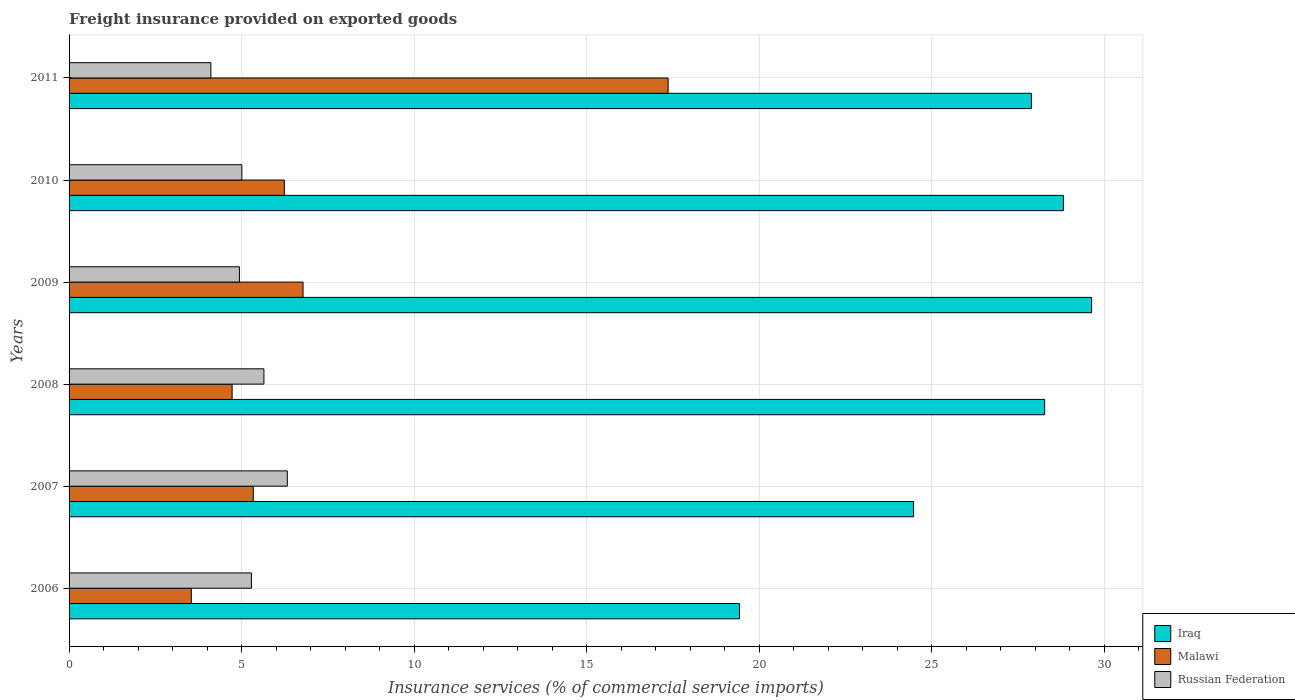How many different coloured bars are there?
Provide a succinct answer. 3. What is the freight insurance provided on exported goods in Malawi in 2010?
Provide a succinct answer. 6.24. Across all years, what is the maximum freight insurance provided on exported goods in Russian Federation?
Provide a succinct answer. 6.33. Across all years, what is the minimum freight insurance provided on exported goods in Russian Federation?
Your answer should be very brief. 4.11. In which year was the freight insurance provided on exported goods in Malawi minimum?
Your response must be concise. 2006. What is the total freight insurance provided on exported goods in Iraq in the graph?
Offer a very short reply. 158.54. What is the difference between the freight insurance provided on exported goods in Iraq in 2009 and that in 2010?
Your answer should be compact. 0.82. What is the difference between the freight insurance provided on exported goods in Russian Federation in 2009 and the freight insurance provided on exported goods in Iraq in 2007?
Keep it short and to the point. -19.54. What is the average freight insurance provided on exported goods in Malawi per year?
Offer a very short reply. 7.33. In the year 2007, what is the difference between the freight insurance provided on exported goods in Malawi and freight insurance provided on exported goods in Russian Federation?
Provide a succinct answer. -0.99. What is the ratio of the freight insurance provided on exported goods in Iraq in 2006 to that in 2011?
Ensure brevity in your answer.  0.7. Is the difference between the freight insurance provided on exported goods in Malawi in 2007 and 2010 greater than the difference between the freight insurance provided on exported goods in Russian Federation in 2007 and 2010?
Give a very brief answer. No. What is the difference between the highest and the second highest freight insurance provided on exported goods in Russian Federation?
Ensure brevity in your answer.  0.68. What is the difference between the highest and the lowest freight insurance provided on exported goods in Malawi?
Offer a very short reply. 13.82. In how many years, is the freight insurance provided on exported goods in Iraq greater than the average freight insurance provided on exported goods in Iraq taken over all years?
Provide a succinct answer. 4. Is the sum of the freight insurance provided on exported goods in Russian Federation in 2006 and 2007 greater than the maximum freight insurance provided on exported goods in Malawi across all years?
Offer a terse response. No. What does the 2nd bar from the top in 2010 represents?
Keep it short and to the point. Malawi. What does the 2nd bar from the bottom in 2010 represents?
Your answer should be compact. Malawi. Is it the case that in every year, the sum of the freight insurance provided on exported goods in Russian Federation and freight insurance provided on exported goods in Malawi is greater than the freight insurance provided on exported goods in Iraq?
Offer a terse response. No. How many bars are there?
Your response must be concise. 18. How many years are there in the graph?
Your answer should be very brief. 6. Are the values on the major ticks of X-axis written in scientific E-notation?
Your response must be concise. No. How are the legend labels stacked?
Your answer should be very brief. Vertical. What is the title of the graph?
Offer a terse response. Freight insurance provided on exported goods. What is the label or title of the X-axis?
Provide a succinct answer. Insurance services (% of commercial service imports). What is the Insurance services (% of commercial service imports) of Iraq in 2006?
Provide a short and direct response. 19.43. What is the Insurance services (% of commercial service imports) in Malawi in 2006?
Provide a short and direct response. 3.54. What is the Insurance services (% of commercial service imports) in Russian Federation in 2006?
Provide a short and direct response. 5.29. What is the Insurance services (% of commercial service imports) in Iraq in 2007?
Make the answer very short. 24.48. What is the Insurance services (% of commercial service imports) of Malawi in 2007?
Make the answer very short. 5.34. What is the Insurance services (% of commercial service imports) of Russian Federation in 2007?
Make the answer very short. 6.33. What is the Insurance services (% of commercial service imports) of Iraq in 2008?
Offer a terse response. 28.28. What is the Insurance services (% of commercial service imports) in Malawi in 2008?
Ensure brevity in your answer.  4.73. What is the Insurance services (% of commercial service imports) in Russian Federation in 2008?
Keep it short and to the point. 5.65. What is the Insurance services (% of commercial service imports) in Iraq in 2009?
Give a very brief answer. 29.64. What is the Insurance services (% of commercial service imports) of Malawi in 2009?
Your answer should be compact. 6.78. What is the Insurance services (% of commercial service imports) of Russian Federation in 2009?
Keep it short and to the point. 4.94. What is the Insurance services (% of commercial service imports) in Iraq in 2010?
Offer a terse response. 28.82. What is the Insurance services (% of commercial service imports) of Malawi in 2010?
Make the answer very short. 6.24. What is the Insurance services (% of commercial service imports) of Russian Federation in 2010?
Your answer should be very brief. 5.01. What is the Insurance services (% of commercial service imports) of Iraq in 2011?
Your answer should be very brief. 27.89. What is the Insurance services (% of commercial service imports) of Malawi in 2011?
Offer a terse response. 17.36. What is the Insurance services (% of commercial service imports) in Russian Federation in 2011?
Ensure brevity in your answer.  4.11. Across all years, what is the maximum Insurance services (% of commercial service imports) in Iraq?
Your response must be concise. 29.64. Across all years, what is the maximum Insurance services (% of commercial service imports) in Malawi?
Give a very brief answer. 17.36. Across all years, what is the maximum Insurance services (% of commercial service imports) in Russian Federation?
Provide a succinct answer. 6.33. Across all years, what is the minimum Insurance services (% of commercial service imports) in Iraq?
Provide a short and direct response. 19.43. Across all years, what is the minimum Insurance services (% of commercial service imports) in Malawi?
Your answer should be compact. 3.54. Across all years, what is the minimum Insurance services (% of commercial service imports) of Russian Federation?
Make the answer very short. 4.11. What is the total Insurance services (% of commercial service imports) in Iraq in the graph?
Keep it short and to the point. 158.54. What is the total Insurance services (% of commercial service imports) of Malawi in the graph?
Give a very brief answer. 43.99. What is the total Insurance services (% of commercial service imports) in Russian Federation in the graph?
Give a very brief answer. 31.32. What is the difference between the Insurance services (% of commercial service imports) of Iraq in 2006 and that in 2007?
Your answer should be very brief. -5.05. What is the difference between the Insurance services (% of commercial service imports) of Malawi in 2006 and that in 2007?
Give a very brief answer. -1.79. What is the difference between the Insurance services (% of commercial service imports) in Russian Federation in 2006 and that in 2007?
Keep it short and to the point. -1.04. What is the difference between the Insurance services (% of commercial service imports) in Iraq in 2006 and that in 2008?
Give a very brief answer. -8.85. What is the difference between the Insurance services (% of commercial service imports) of Malawi in 2006 and that in 2008?
Provide a succinct answer. -1.18. What is the difference between the Insurance services (% of commercial service imports) in Russian Federation in 2006 and that in 2008?
Your answer should be very brief. -0.36. What is the difference between the Insurance services (% of commercial service imports) of Iraq in 2006 and that in 2009?
Offer a very short reply. -10.21. What is the difference between the Insurance services (% of commercial service imports) in Malawi in 2006 and that in 2009?
Make the answer very short. -3.24. What is the difference between the Insurance services (% of commercial service imports) of Russian Federation in 2006 and that in 2009?
Make the answer very short. 0.35. What is the difference between the Insurance services (% of commercial service imports) in Iraq in 2006 and that in 2010?
Offer a terse response. -9.39. What is the difference between the Insurance services (% of commercial service imports) in Malawi in 2006 and that in 2010?
Ensure brevity in your answer.  -2.7. What is the difference between the Insurance services (% of commercial service imports) in Russian Federation in 2006 and that in 2010?
Provide a short and direct response. 0.28. What is the difference between the Insurance services (% of commercial service imports) in Iraq in 2006 and that in 2011?
Give a very brief answer. -8.46. What is the difference between the Insurance services (% of commercial service imports) of Malawi in 2006 and that in 2011?
Provide a short and direct response. -13.82. What is the difference between the Insurance services (% of commercial service imports) of Russian Federation in 2006 and that in 2011?
Offer a terse response. 1.18. What is the difference between the Insurance services (% of commercial service imports) in Iraq in 2007 and that in 2008?
Your answer should be very brief. -3.8. What is the difference between the Insurance services (% of commercial service imports) of Malawi in 2007 and that in 2008?
Offer a very short reply. 0.61. What is the difference between the Insurance services (% of commercial service imports) in Russian Federation in 2007 and that in 2008?
Offer a very short reply. 0.68. What is the difference between the Insurance services (% of commercial service imports) in Iraq in 2007 and that in 2009?
Provide a short and direct response. -5.16. What is the difference between the Insurance services (% of commercial service imports) of Malawi in 2007 and that in 2009?
Keep it short and to the point. -1.44. What is the difference between the Insurance services (% of commercial service imports) of Russian Federation in 2007 and that in 2009?
Keep it short and to the point. 1.39. What is the difference between the Insurance services (% of commercial service imports) of Iraq in 2007 and that in 2010?
Make the answer very short. -4.34. What is the difference between the Insurance services (% of commercial service imports) in Malawi in 2007 and that in 2010?
Offer a very short reply. -0.9. What is the difference between the Insurance services (% of commercial service imports) in Russian Federation in 2007 and that in 2010?
Keep it short and to the point. 1.32. What is the difference between the Insurance services (% of commercial service imports) of Iraq in 2007 and that in 2011?
Give a very brief answer. -3.42. What is the difference between the Insurance services (% of commercial service imports) in Malawi in 2007 and that in 2011?
Provide a short and direct response. -12.02. What is the difference between the Insurance services (% of commercial service imports) in Russian Federation in 2007 and that in 2011?
Your response must be concise. 2.22. What is the difference between the Insurance services (% of commercial service imports) in Iraq in 2008 and that in 2009?
Ensure brevity in your answer.  -1.36. What is the difference between the Insurance services (% of commercial service imports) of Malawi in 2008 and that in 2009?
Offer a terse response. -2.06. What is the difference between the Insurance services (% of commercial service imports) in Russian Federation in 2008 and that in 2009?
Offer a terse response. 0.71. What is the difference between the Insurance services (% of commercial service imports) in Iraq in 2008 and that in 2010?
Ensure brevity in your answer.  -0.54. What is the difference between the Insurance services (% of commercial service imports) of Malawi in 2008 and that in 2010?
Ensure brevity in your answer.  -1.51. What is the difference between the Insurance services (% of commercial service imports) of Russian Federation in 2008 and that in 2010?
Offer a terse response. 0.64. What is the difference between the Insurance services (% of commercial service imports) in Iraq in 2008 and that in 2011?
Your answer should be very brief. 0.38. What is the difference between the Insurance services (% of commercial service imports) of Malawi in 2008 and that in 2011?
Keep it short and to the point. -12.64. What is the difference between the Insurance services (% of commercial service imports) of Russian Federation in 2008 and that in 2011?
Provide a short and direct response. 1.54. What is the difference between the Insurance services (% of commercial service imports) of Iraq in 2009 and that in 2010?
Offer a terse response. 0.82. What is the difference between the Insurance services (% of commercial service imports) of Malawi in 2009 and that in 2010?
Offer a terse response. 0.54. What is the difference between the Insurance services (% of commercial service imports) of Russian Federation in 2009 and that in 2010?
Offer a terse response. -0.07. What is the difference between the Insurance services (% of commercial service imports) of Iraq in 2009 and that in 2011?
Your answer should be compact. 1.75. What is the difference between the Insurance services (% of commercial service imports) in Malawi in 2009 and that in 2011?
Make the answer very short. -10.58. What is the difference between the Insurance services (% of commercial service imports) of Russian Federation in 2009 and that in 2011?
Your response must be concise. 0.83. What is the difference between the Insurance services (% of commercial service imports) of Iraq in 2010 and that in 2011?
Make the answer very short. 0.93. What is the difference between the Insurance services (% of commercial service imports) of Malawi in 2010 and that in 2011?
Give a very brief answer. -11.12. What is the difference between the Insurance services (% of commercial service imports) of Russian Federation in 2010 and that in 2011?
Your response must be concise. 0.9. What is the difference between the Insurance services (% of commercial service imports) in Iraq in 2006 and the Insurance services (% of commercial service imports) in Malawi in 2007?
Provide a short and direct response. 14.09. What is the difference between the Insurance services (% of commercial service imports) of Iraq in 2006 and the Insurance services (% of commercial service imports) of Russian Federation in 2007?
Ensure brevity in your answer.  13.11. What is the difference between the Insurance services (% of commercial service imports) of Malawi in 2006 and the Insurance services (% of commercial service imports) of Russian Federation in 2007?
Provide a succinct answer. -2.78. What is the difference between the Insurance services (% of commercial service imports) of Iraq in 2006 and the Insurance services (% of commercial service imports) of Malawi in 2008?
Provide a succinct answer. 14.71. What is the difference between the Insurance services (% of commercial service imports) of Iraq in 2006 and the Insurance services (% of commercial service imports) of Russian Federation in 2008?
Your answer should be compact. 13.78. What is the difference between the Insurance services (% of commercial service imports) in Malawi in 2006 and the Insurance services (% of commercial service imports) in Russian Federation in 2008?
Your answer should be very brief. -2.1. What is the difference between the Insurance services (% of commercial service imports) of Iraq in 2006 and the Insurance services (% of commercial service imports) of Malawi in 2009?
Offer a terse response. 12.65. What is the difference between the Insurance services (% of commercial service imports) of Iraq in 2006 and the Insurance services (% of commercial service imports) of Russian Federation in 2009?
Keep it short and to the point. 14.49. What is the difference between the Insurance services (% of commercial service imports) of Malawi in 2006 and the Insurance services (% of commercial service imports) of Russian Federation in 2009?
Provide a short and direct response. -1.39. What is the difference between the Insurance services (% of commercial service imports) of Iraq in 2006 and the Insurance services (% of commercial service imports) of Malawi in 2010?
Offer a terse response. 13.19. What is the difference between the Insurance services (% of commercial service imports) of Iraq in 2006 and the Insurance services (% of commercial service imports) of Russian Federation in 2010?
Give a very brief answer. 14.42. What is the difference between the Insurance services (% of commercial service imports) of Malawi in 2006 and the Insurance services (% of commercial service imports) of Russian Federation in 2010?
Keep it short and to the point. -1.46. What is the difference between the Insurance services (% of commercial service imports) of Iraq in 2006 and the Insurance services (% of commercial service imports) of Malawi in 2011?
Give a very brief answer. 2.07. What is the difference between the Insurance services (% of commercial service imports) of Iraq in 2006 and the Insurance services (% of commercial service imports) of Russian Federation in 2011?
Provide a succinct answer. 15.32. What is the difference between the Insurance services (% of commercial service imports) of Malawi in 2006 and the Insurance services (% of commercial service imports) of Russian Federation in 2011?
Offer a very short reply. -0.57. What is the difference between the Insurance services (% of commercial service imports) of Iraq in 2007 and the Insurance services (% of commercial service imports) of Malawi in 2008?
Give a very brief answer. 19.75. What is the difference between the Insurance services (% of commercial service imports) in Iraq in 2007 and the Insurance services (% of commercial service imports) in Russian Federation in 2008?
Provide a short and direct response. 18.83. What is the difference between the Insurance services (% of commercial service imports) of Malawi in 2007 and the Insurance services (% of commercial service imports) of Russian Federation in 2008?
Your answer should be compact. -0.31. What is the difference between the Insurance services (% of commercial service imports) in Iraq in 2007 and the Insurance services (% of commercial service imports) in Malawi in 2009?
Make the answer very short. 17.7. What is the difference between the Insurance services (% of commercial service imports) of Iraq in 2007 and the Insurance services (% of commercial service imports) of Russian Federation in 2009?
Your answer should be compact. 19.54. What is the difference between the Insurance services (% of commercial service imports) of Malawi in 2007 and the Insurance services (% of commercial service imports) of Russian Federation in 2009?
Your response must be concise. 0.4. What is the difference between the Insurance services (% of commercial service imports) of Iraq in 2007 and the Insurance services (% of commercial service imports) of Malawi in 2010?
Offer a terse response. 18.24. What is the difference between the Insurance services (% of commercial service imports) in Iraq in 2007 and the Insurance services (% of commercial service imports) in Russian Federation in 2010?
Provide a short and direct response. 19.47. What is the difference between the Insurance services (% of commercial service imports) of Malawi in 2007 and the Insurance services (% of commercial service imports) of Russian Federation in 2010?
Keep it short and to the point. 0.33. What is the difference between the Insurance services (% of commercial service imports) of Iraq in 2007 and the Insurance services (% of commercial service imports) of Malawi in 2011?
Give a very brief answer. 7.11. What is the difference between the Insurance services (% of commercial service imports) of Iraq in 2007 and the Insurance services (% of commercial service imports) of Russian Federation in 2011?
Provide a short and direct response. 20.37. What is the difference between the Insurance services (% of commercial service imports) in Malawi in 2007 and the Insurance services (% of commercial service imports) in Russian Federation in 2011?
Provide a succinct answer. 1.23. What is the difference between the Insurance services (% of commercial service imports) in Iraq in 2008 and the Insurance services (% of commercial service imports) in Malawi in 2009?
Keep it short and to the point. 21.5. What is the difference between the Insurance services (% of commercial service imports) in Iraq in 2008 and the Insurance services (% of commercial service imports) in Russian Federation in 2009?
Provide a short and direct response. 23.34. What is the difference between the Insurance services (% of commercial service imports) in Malawi in 2008 and the Insurance services (% of commercial service imports) in Russian Federation in 2009?
Offer a terse response. -0.21. What is the difference between the Insurance services (% of commercial service imports) in Iraq in 2008 and the Insurance services (% of commercial service imports) in Malawi in 2010?
Give a very brief answer. 22.04. What is the difference between the Insurance services (% of commercial service imports) of Iraq in 2008 and the Insurance services (% of commercial service imports) of Russian Federation in 2010?
Keep it short and to the point. 23.27. What is the difference between the Insurance services (% of commercial service imports) of Malawi in 2008 and the Insurance services (% of commercial service imports) of Russian Federation in 2010?
Your answer should be compact. -0.28. What is the difference between the Insurance services (% of commercial service imports) in Iraq in 2008 and the Insurance services (% of commercial service imports) in Malawi in 2011?
Provide a short and direct response. 10.91. What is the difference between the Insurance services (% of commercial service imports) of Iraq in 2008 and the Insurance services (% of commercial service imports) of Russian Federation in 2011?
Your answer should be very brief. 24.17. What is the difference between the Insurance services (% of commercial service imports) in Malawi in 2008 and the Insurance services (% of commercial service imports) in Russian Federation in 2011?
Make the answer very short. 0.62. What is the difference between the Insurance services (% of commercial service imports) in Iraq in 2009 and the Insurance services (% of commercial service imports) in Malawi in 2010?
Your answer should be very brief. 23.4. What is the difference between the Insurance services (% of commercial service imports) in Iraq in 2009 and the Insurance services (% of commercial service imports) in Russian Federation in 2010?
Keep it short and to the point. 24.63. What is the difference between the Insurance services (% of commercial service imports) of Malawi in 2009 and the Insurance services (% of commercial service imports) of Russian Federation in 2010?
Provide a short and direct response. 1.77. What is the difference between the Insurance services (% of commercial service imports) of Iraq in 2009 and the Insurance services (% of commercial service imports) of Malawi in 2011?
Provide a succinct answer. 12.28. What is the difference between the Insurance services (% of commercial service imports) of Iraq in 2009 and the Insurance services (% of commercial service imports) of Russian Federation in 2011?
Your answer should be compact. 25.53. What is the difference between the Insurance services (% of commercial service imports) in Malawi in 2009 and the Insurance services (% of commercial service imports) in Russian Federation in 2011?
Your answer should be very brief. 2.67. What is the difference between the Insurance services (% of commercial service imports) in Iraq in 2010 and the Insurance services (% of commercial service imports) in Malawi in 2011?
Ensure brevity in your answer.  11.46. What is the difference between the Insurance services (% of commercial service imports) of Iraq in 2010 and the Insurance services (% of commercial service imports) of Russian Federation in 2011?
Give a very brief answer. 24.71. What is the difference between the Insurance services (% of commercial service imports) of Malawi in 2010 and the Insurance services (% of commercial service imports) of Russian Federation in 2011?
Provide a short and direct response. 2.13. What is the average Insurance services (% of commercial service imports) in Iraq per year?
Your response must be concise. 26.42. What is the average Insurance services (% of commercial service imports) in Malawi per year?
Your answer should be compact. 7.33. What is the average Insurance services (% of commercial service imports) of Russian Federation per year?
Offer a terse response. 5.22. In the year 2006, what is the difference between the Insurance services (% of commercial service imports) of Iraq and Insurance services (% of commercial service imports) of Malawi?
Offer a terse response. 15.89. In the year 2006, what is the difference between the Insurance services (% of commercial service imports) of Iraq and Insurance services (% of commercial service imports) of Russian Federation?
Offer a very short reply. 14.15. In the year 2006, what is the difference between the Insurance services (% of commercial service imports) of Malawi and Insurance services (% of commercial service imports) of Russian Federation?
Ensure brevity in your answer.  -1.74. In the year 2007, what is the difference between the Insurance services (% of commercial service imports) of Iraq and Insurance services (% of commercial service imports) of Malawi?
Ensure brevity in your answer.  19.14. In the year 2007, what is the difference between the Insurance services (% of commercial service imports) of Iraq and Insurance services (% of commercial service imports) of Russian Federation?
Provide a succinct answer. 18.15. In the year 2007, what is the difference between the Insurance services (% of commercial service imports) in Malawi and Insurance services (% of commercial service imports) in Russian Federation?
Keep it short and to the point. -0.99. In the year 2008, what is the difference between the Insurance services (% of commercial service imports) in Iraq and Insurance services (% of commercial service imports) in Malawi?
Provide a short and direct response. 23.55. In the year 2008, what is the difference between the Insurance services (% of commercial service imports) of Iraq and Insurance services (% of commercial service imports) of Russian Federation?
Your answer should be compact. 22.63. In the year 2008, what is the difference between the Insurance services (% of commercial service imports) in Malawi and Insurance services (% of commercial service imports) in Russian Federation?
Your answer should be very brief. -0.92. In the year 2009, what is the difference between the Insurance services (% of commercial service imports) of Iraq and Insurance services (% of commercial service imports) of Malawi?
Make the answer very short. 22.86. In the year 2009, what is the difference between the Insurance services (% of commercial service imports) in Iraq and Insurance services (% of commercial service imports) in Russian Federation?
Your response must be concise. 24.7. In the year 2009, what is the difference between the Insurance services (% of commercial service imports) in Malawi and Insurance services (% of commercial service imports) in Russian Federation?
Provide a short and direct response. 1.84. In the year 2010, what is the difference between the Insurance services (% of commercial service imports) of Iraq and Insurance services (% of commercial service imports) of Malawi?
Give a very brief answer. 22.58. In the year 2010, what is the difference between the Insurance services (% of commercial service imports) of Iraq and Insurance services (% of commercial service imports) of Russian Federation?
Your response must be concise. 23.81. In the year 2010, what is the difference between the Insurance services (% of commercial service imports) in Malawi and Insurance services (% of commercial service imports) in Russian Federation?
Your answer should be compact. 1.23. In the year 2011, what is the difference between the Insurance services (% of commercial service imports) of Iraq and Insurance services (% of commercial service imports) of Malawi?
Offer a very short reply. 10.53. In the year 2011, what is the difference between the Insurance services (% of commercial service imports) in Iraq and Insurance services (% of commercial service imports) in Russian Federation?
Provide a short and direct response. 23.78. In the year 2011, what is the difference between the Insurance services (% of commercial service imports) in Malawi and Insurance services (% of commercial service imports) in Russian Federation?
Provide a succinct answer. 13.25. What is the ratio of the Insurance services (% of commercial service imports) of Iraq in 2006 to that in 2007?
Ensure brevity in your answer.  0.79. What is the ratio of the Insurance services (% of commercial service imports) in Malawi in 2006 to that in 2007?
Your response must be concise. 0.66. What is the ratio of the Insurance services (% of commercial service imports) of Russian Federation in 2006 to that in 2007?
Your answer should be very brief. 0.84. What is the ratio of the Insurance services (% of commercial service imports) in Iraq in 2006 to that in 2008?
Make the answer very short. 0.69. What is the ratio of the Insurance services (% of commercial service imports) of Malawi in 2006 to that in 2008?
Your response must be concise. 0.75. What is the ratio of the Insurance services (% of commercial service imports) in Russian Federation in 2006 to that in 2008?
Your answer should be compact. 0.94. What is the ratio of the Insurance services (% of commercial service imports) of Iraq in 2006 to that in 2009?
Your answer should be very brief. 0.66. What is the ratio of the Insurance services (% of commercial service imports) in Malawi in 2006 to that in 2009?
Give a very brief answer. 0.52. What is the ratio of the Insurance services (% of commercial service imports) of Russian Federation in 2006 to that in 2009?
Ensure brevity in your answer.  1.07. What is the ratio of the Insurance services (% of commercial service imports) in Iraq in 2006 to that in 2010?
Ensure brevity in your answer.  0.67. What is the ratio of the Insurance services (% of commercial service imports) in Malawi in 2006 to that in 2010?
Offer a very short reply. 0.57. What is the ratio of the Insurance services (% of commercial service imports) of Russian Federation in 2006 to that in 2010?
Your answer should be very brief. 1.06. What is the ratio of the Insurance services (% of commercial service imports) in Iraq in 2006 to that in 2011?
Offer a very short reply. 0.7. What is the ratio of the Insurance services (% of commercial service imports) of Malawi in 2006 to that in 2011?
Your answer should be very brief. 0.2. What is the ratio of the Insurance services (% of commercial service imports) in Russian Federation in 2006 to that in 2011?
Your response must be concise. 1.29. What is the ratio of the Insurance services (% of commercial service imports) of Iraq in 2007 to that in 2008?
Keep it short and to the point. 0.87. What is the ratio of the Insurance services (% of commercial service imports) in Malawi in 2007 to that in 2008?
Offer a very short reply. 1.13. What is the ratio of the Insurance services (% of commercial service imports) of Russian Federation in 2007 to that in 2008?
Keep it short and to the point. 1.12. What is the ratio of the Insurance services (% of commercial service imports) in Iraq in 2007 to that in 2009?
Offer a very short reply. 0.83. What is the ratio of the Insurance services (% of commercial service imports) of Malawi in 2007 to that in 2009?
Provide a short and direct response. 0.79. What is the ratio of the Insurance services (% of commercial service imports) in Russian Federation in 2007 to that in 2009?
Your answer should be compact. 1.28. What is the ratio of the Insurance services (% of commercial service imports) in Iraq in 2007 to that in 2010?
Give a very brief answer. 0.85. What is the ratio of the Insurance services (% of commercial service imports) of Malawi in 2007 to that in 2010?
Make the answer very short. 0.86. What is the ratio of the Insurance services (% of commercial service imports) in Russian Federation in 2007 to that in 2010?
Keep it short and to the point. 1.26. What is the ratio of the Insurance services (% of commercial service imports) of Iraq in 2007 to that in 2011?
Your response must be concise. 0.88. What is the ratio of the Insurance services (% of commercial service imports) in Malawi in 2007 to that in 2011?
Offer a terse response. 0.31. What is the ratio of the Insurance services (% of commercial service imports) in Russian Federation in 2007 to that in 2011?
Make the answer very short. 1.54. What is the ratio of the Insurance services (% of commercial service imports) in Iraq in 2008 to that in 2009?
Make the answer very short. 0.95. What is the ratio of the Insurance services (% of commercial service imports) in Malawi in 2008 to that in 2009?
Your answer should be compact. 0.7. What is the ratio of the Insurance services (% of commercial service imports) of Russian Federation in 2008 to that in 2009?
Keep it short and to the point. 1.14. What is the ratio of the Insurance services (% of commercial service imports) in Iraq in 2008 to that in 2010?
Keep it short and to the point. 0.98. What is the ratio of the Insurance services (% of commercial service imports) in Malawi in 2008 to that in 2010?
Keep it short and to the point. 0.76. What is the ratio of the Insurance services (% of commercial service imports) in Russian Federation in 2008 to that in 2010?
Keep it short and to the point. 1.13. What is the ratio of the Insurance services (% of commercial service imports) in Iraq in 2008 to that in 2011?
Your response must be concise. 1.01. What is the ratio of the Insurance services (% of commercial service imports) in Malawi in 2008 to that in 2011?
Keep it short and to the point. 0.27. What is the ratio of the Insurance services (% of commercial service imports) in Russian Federation in 2008 to that in 2011?
Keep it short and to the point. 1.37. What is the ratio of the Insurance services (% of commercial service imports) of Iraq in 2009 to that in 2010?
Keep it short and to the point. 1.03. What is the ratio of the Insurance services (% of commercial service imports) of Malawi in 2009 to that in 2010?
Make the answer very short. 1.09. What is the ratio of the Insurance services (% of commercial service imports) in Iraq in 2009 to that in 2011?
Offer a very short reply. 1.06. What is the ratio of the Insurance services (% of commercial service imports) in Malawi in 2009 to that in 2011?
Make the answer very short. 0.39. What is the ratio of the Insurance services (% of commercial service imports) of Russian Federation in 2009 to that in 2011?
Make the answer very short. 1.2. What is the ratio of the Insurance services (% of commercial service imports) of Iraq in 2010 to that in 2011?
Provide a succinct answer. 1.03. What is the ratio of the Insurance services (% of commercial service imports) in Malawi in 2010 to that in 2011?
Make the answer very short. 0.36. What is the ratio of the Insurance services (% of commercial service imports) of Russian Federation in 2010 to that in 2011?
Offer a terse response. 1.22. What is the difference between the highest and the second highest Insurance services (% of commercial service imports) of Iraq?
Give a very brief answer. 0.82. What is the difference between the highest and the second highest Insurance services (% of commercial service imports) in Malawi?
Provide a short and direct response. 10.58. What is the difference between the highest and the second highest Insurance services (% of commercial service imports) in Russian Federation?
Your answer should be compact. 0.68. What is the difference between the highest and the lowest Insurance services (% of commercial service imports) in Iraq?
Your answer should be compact. 10.21. What is the difference between the highest and the lowest Insurance services (% of commercial service imports) in Malawi?
Offer a terse response. 13.82. What is the difference between the highest and the lowest Insurance services (% of commercial service imports) in Russian Federation?
Ensure brevity in your answer.  2.22. 